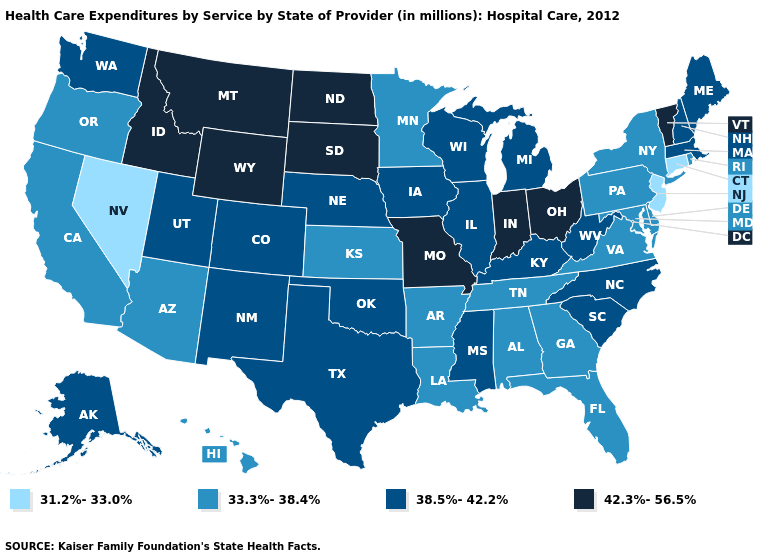Does Vermont have a higher value than North Dakota?
Be succinct. No. Name the states that have a value in the range 33.3%-38.4%?
Concise answer only. Alabama, Arizona, Arkansas, California, Delaware, Florida, Georgia, Hawaii, Kansas, Louisiana, Maryland, Minnesota, New York, Oregon, Pennsylvania, Rhode Island, Tennessee, Virginia. Does the first symbol in the legend represent the smallest category?
Keep it brief. Yes. Does Kansas have the same value as Vermont?
Be succinct. No. Does Indiana have the highest value in the MidWest?
Keep it brief. Yes. What is the value of Oregon?
Concise answer only. 33.3%-38.4%. Does Rhode Island have a higher value than Nevada?
Answer briefly. Yes. Name the states that have a value in the range 31.2%-33.0%?
Write a very short answer. Connecticut, Nevada, New Jersey. What is the value of Maryland?
Write a very short answer. 33.3%-38.4%. What is the lowest value in states that border Kentucky?
Keep it brief. 33.3%-38.4%. What is the value of New Jersey?
Keep it brief. 31.2%-33.0%. What is the highest value in states that border Ohio?
Be succinct. 42.3%-56.5%. Which states hav the highest value in the West?
Be succinct. Idaho, Montana, Wyoming. Does the first symbol in the legend represent the smallest category?
Concise answer only. Yes. What is the value of New York?
Be succinct. 33.3%-38.4%. 